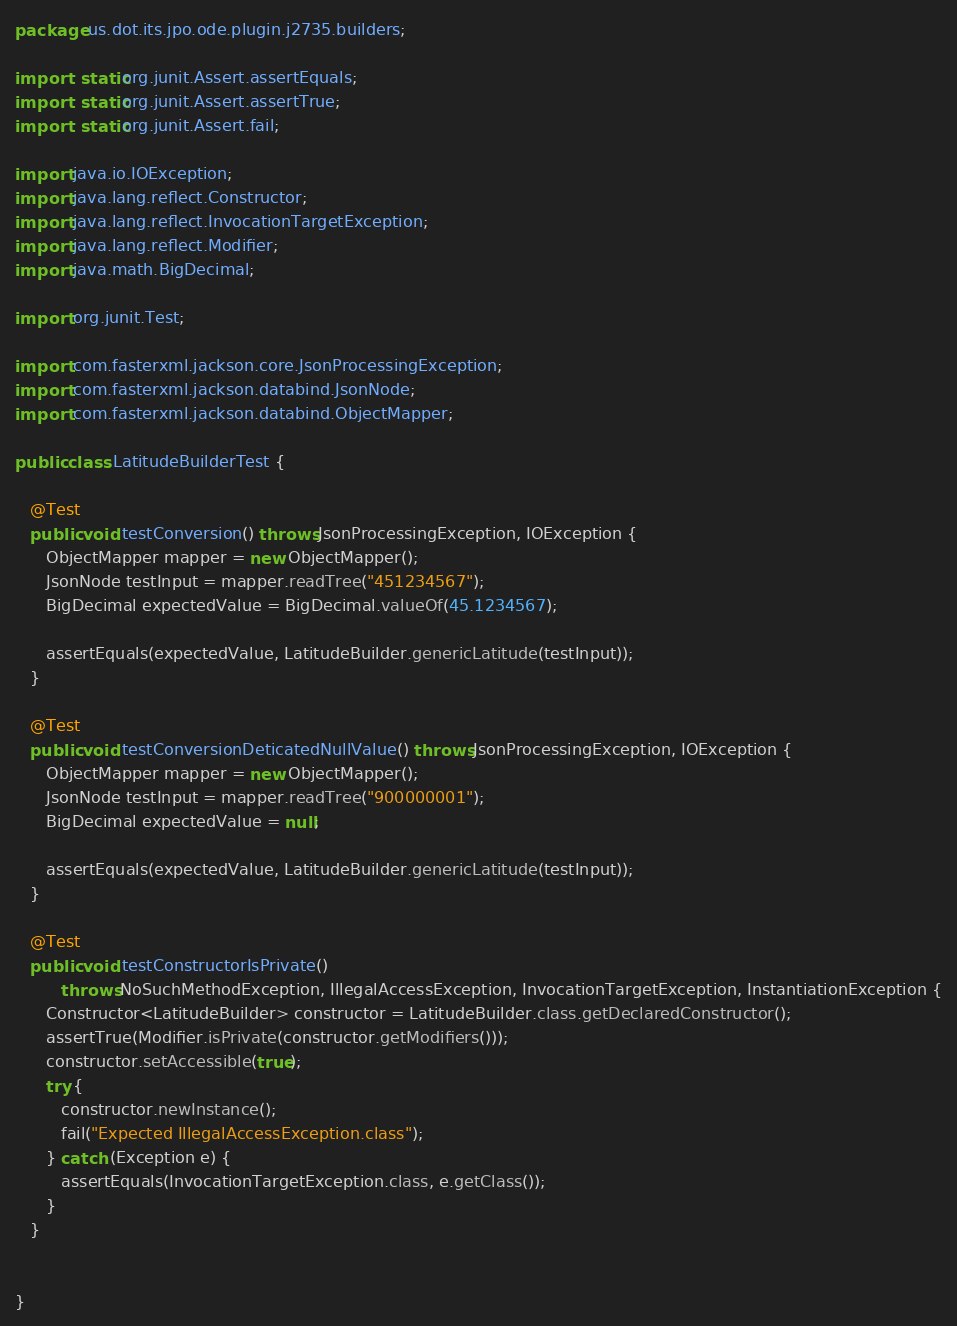<code> <loc_0><loc_0><loc_500><loc_500><_Java_>package us.dot.its.jpo.ode.plugin.j2735.builders;

import static org.junit.Assert.assertEquals;
import static org.junit.Assert.assertTrue;
import static org.junit.Assert.fail;

import java.io.IOException;
import java.lang.reflect.Constructor;
import java.lang.reflect.InvocationTargetException;
import java.lang.reflect.Modifier;
import java.math.BigDecimal;

import org.junit.Test;

import com.fasterxml.jackson.core.JsonProcessingException;
import com.fasterxml.jackson.databind.JsonNode;
import com.fasterxml.jackson.databind.ObjectMapper;

public class LatitudeBuilderTest {

   @Test
   public void testConversion() throws JsonProcessingException, IOException {
      ObjectMapper mapper = new ObjectMapper();
      JsonNode testInput = mapper.readTree("451234567");
      BigDecimal expectedValue = BigDecimal.valueOf(45.1234567);

      assertEquals(expectedValue, LatitudeBuilder.genericLatitude(testInput));
   }
   
   @Test
   public void testConversionDeticatedNullValue() throws JsonProcessingException, IOException {
      ObjectMapper mapper = new ObjectMapper();
      JsonNode testInput = mapper.readTree("900000001");
      BigDecimal expectedValue = null;

      assertEquals(expectedValue, LatitudeBuilder.genericLatitude(testInput));
   }
   
   @Test
   public void testConstructorIsPrivate()
         throws NoSuchMethodException, IllegalAccessException, InvocationTargetException, InstantiationException {
      Constructor<LatitudeBuilder> constructor = LatitudeBuilder.class.getDeclaredConstructor();
      assertTrue(Modifier.isPrivate(constructor.getModifiers()));
      constructor.setAccessible(true);
      try {
         constructor.newInstance();
         fail("Expected IllegalAccessException.class");
      } catch (Exception e) {
         assertEquals(InvocationTargetException.class, e.getClass());
      }
   }
   
   
}
</code> 